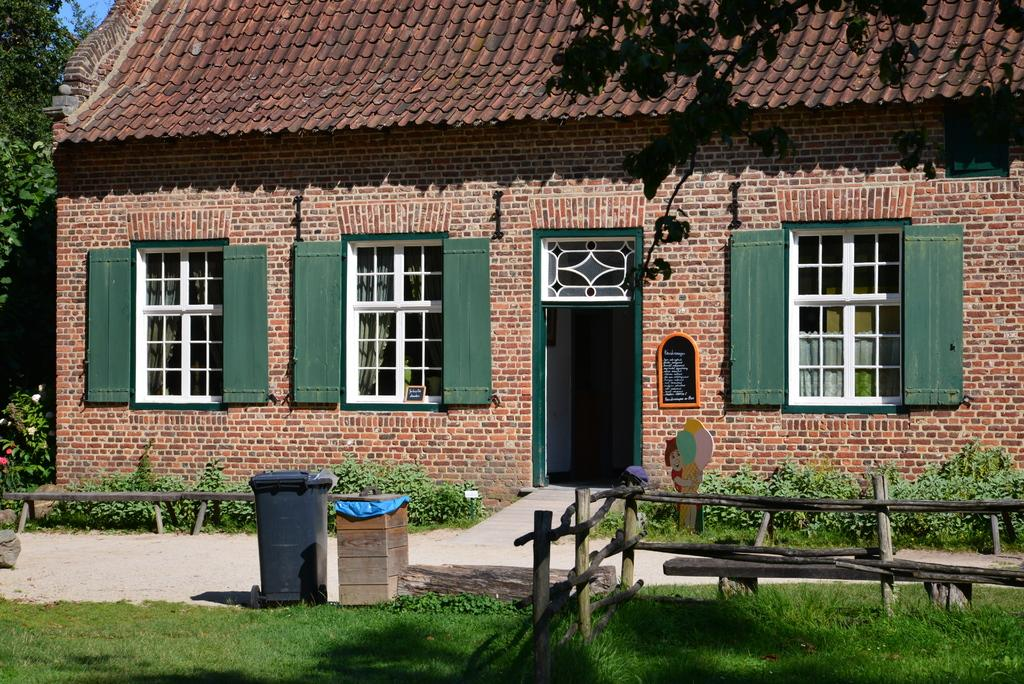What type of structure is visible in the image? There is a house in the image. What can be seen on the house in the image? The house has windows that are opened and a door. What is present in front of the house in the image? There is a path, trees, grass, wooden sticks, and a bin in front of the house. What is the board used for in the image? The purpose of the board in the image is not specified, but it is present. Can you see an airplane flying over the house in the image? No, there is no airplane visible in the image. Is there a scarf hanging from the trees in front of the house? No, there is no scarf present in the image. 